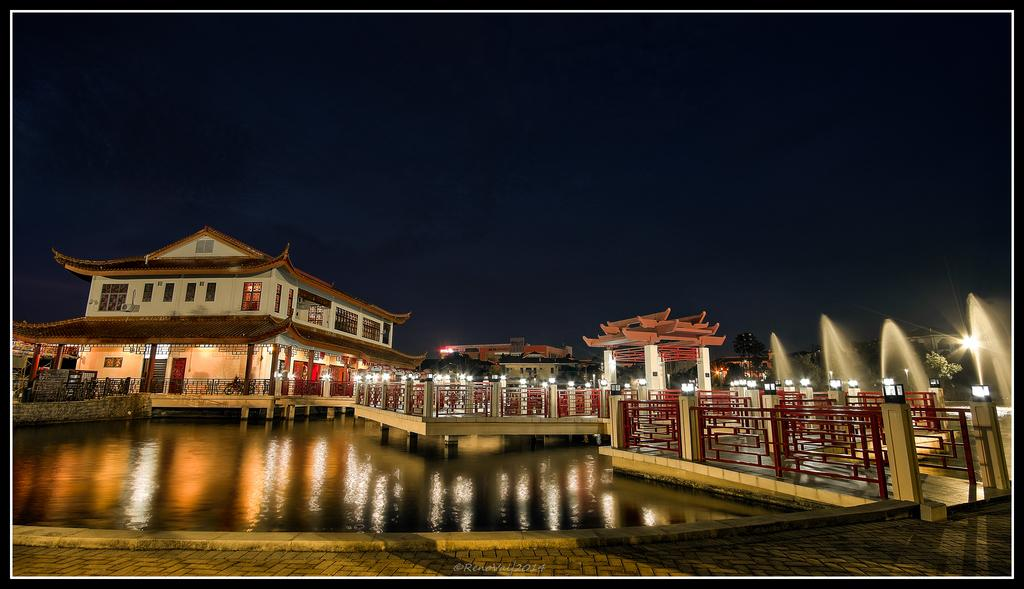What type of structure is present in the image? There is a building in the image. What can be seen illuminating the area in the image? There are lights in the image. What type of feature is present in the image that involves water? There is a water fountain in the image. Can you describe the water in the image? There is water visible in the image. What part of the natural environment is visible in the image? The sky is visible in the image. Where is the crowd gathered in the image? There is no crowd present in the image. What type of engine is powering the water fountain in the image? There is no engine present in the image, and the water fountain's power source is not visible. 